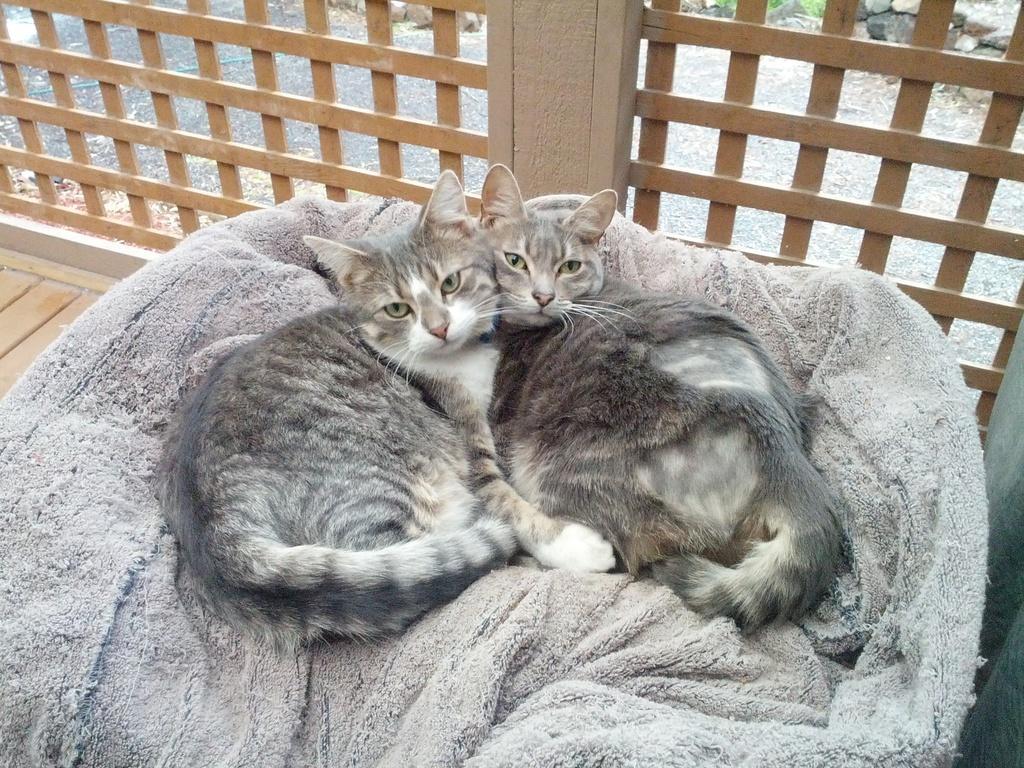Describe this image in one or two sentences. In this image, we can see cats on bed. There are wooden grills at the top of the image. 